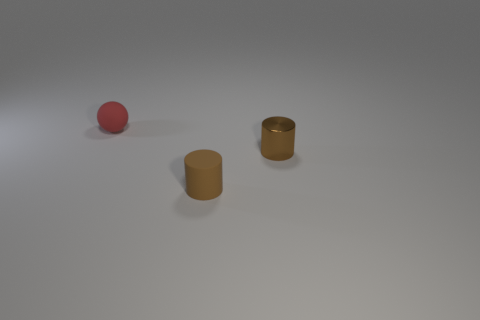Subtract 1 balls. How many balls are left? 0 Subtract all spheres. How many objects are left? 2 Add 2 metal things. How many objects exist? 5 Subtract 0 red cylinders. How many objects are left? 3 Subtract all purple cylinders. Subtract all blue cubes. How many cylinders are left? 2 Subtract all large brown cylinders. Subtract all small brown objects. How many objects are left? 1 Add 1 cylinders. How many cylinders are left? 3 Add 2 small metal cylinders. How many small metal cylinders exist? 3 